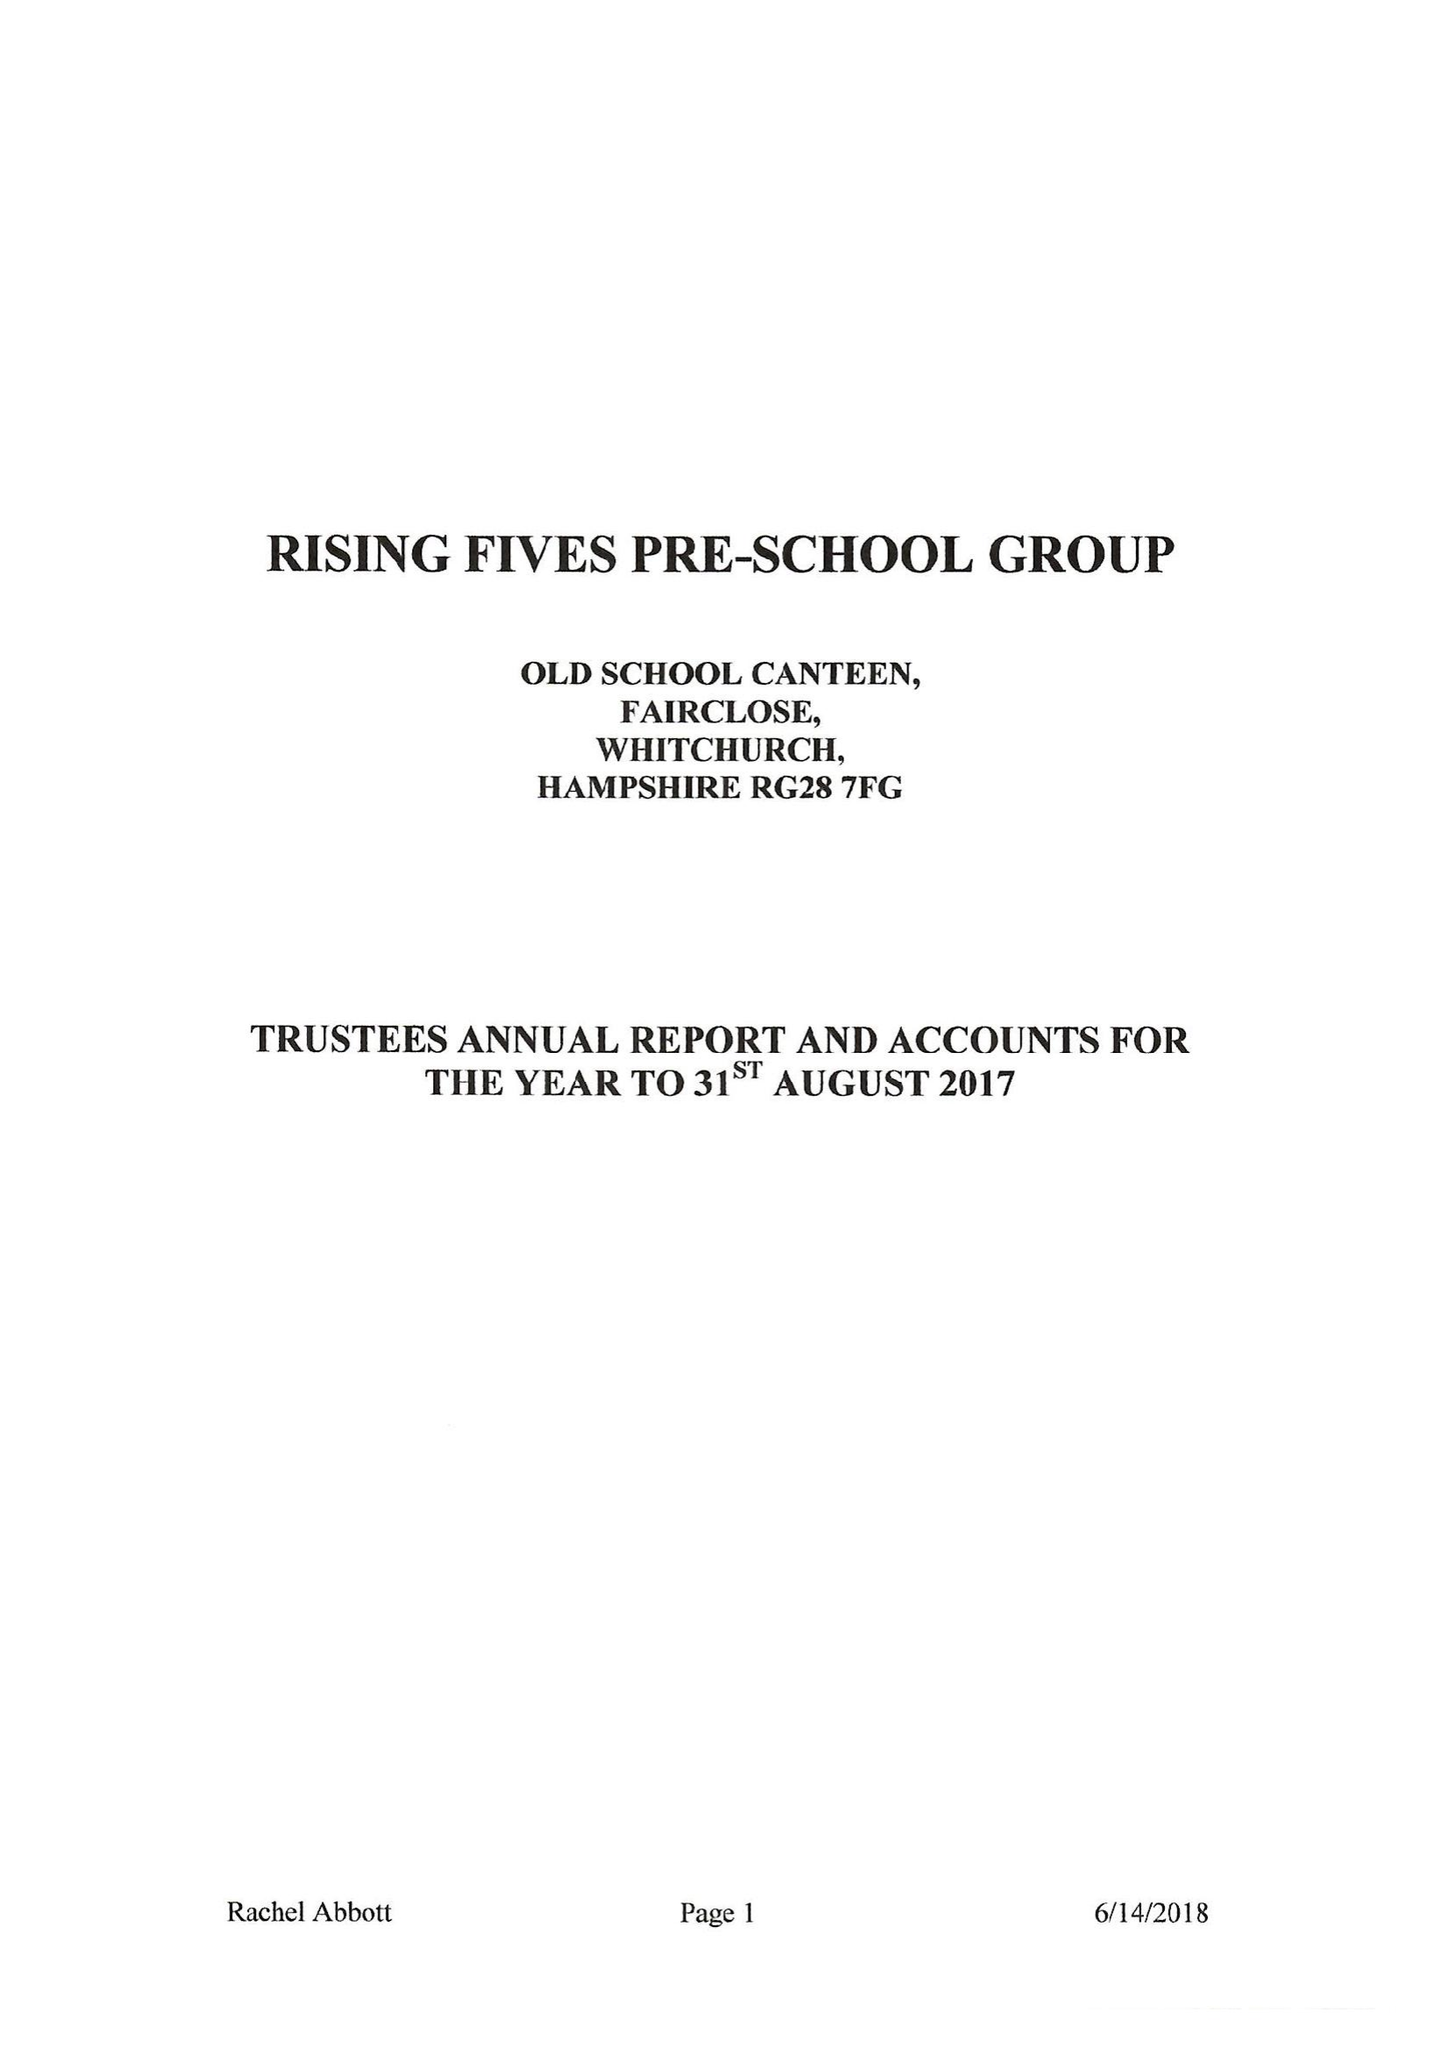What is the value for the spending_annually_in_british_pounds?
Answer the question using a single word or phrase. 84860.00 